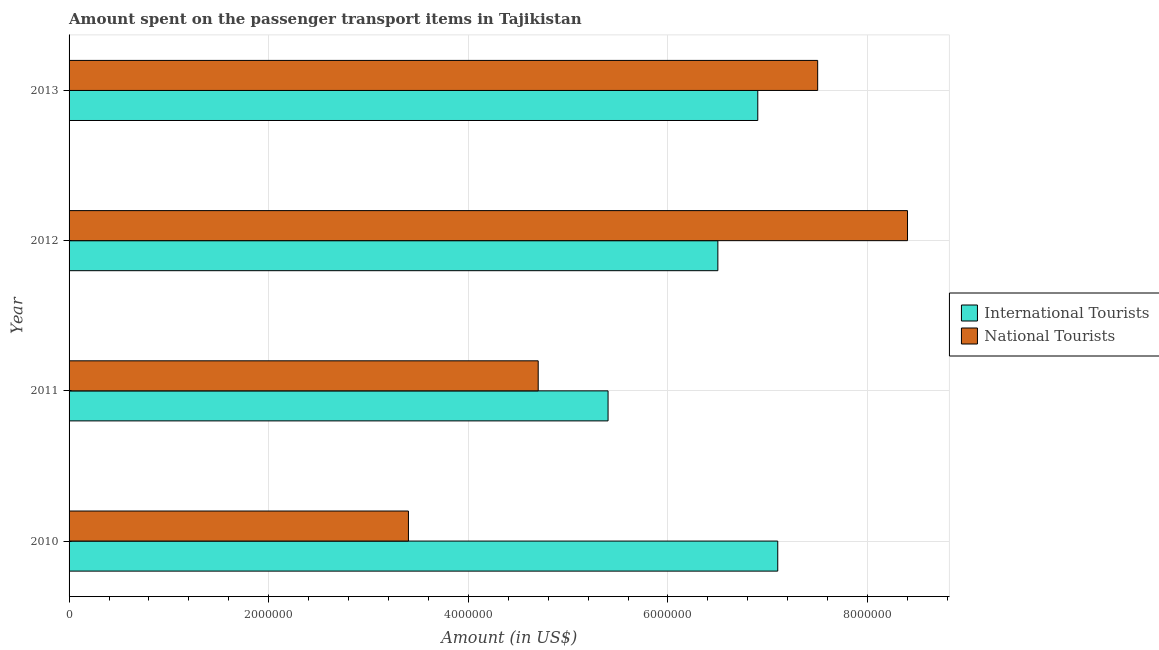How many different coloured bars are there?
Ensure brevity in your answer.  2. Are the number of bars per tick equal to the number of legend labels?
Provide a short and direct response. Yes. What is the amount spent on transport items of national tourists in 2012?
Provide a short and direct response. 8.40e+06. Across all years, what is the maximum amount spent on transport items of international tourists?
Keep it short and to the point. 7.10e+06. Across all years, what is the minimum amount spent on transport items of international tourists?
Your answer should be very brief. 5.40e+06. In which year was the amount spent on transport items of national tourists maximum?
Your response must be concise. 2012. In which year was the amount spent on transport items of national tourists minimum?
Offer a terse response. 2010. What is the total amount spent on transport items of international tourists in the graph?
Your answer should be very brief. 2.59e+07. What is the difference between the amount spent on transport items of national tourists in 2010 and that in 2012?
Give a very brief answer. -5.00e+06. What is the difference between the amount spent on transport items of international tourists in 2011 and the amount spent on transport items of national tourists in 2013?
Provide a short and direct response. -2.10e+06. What is the average amount spent on transport items of international tourists per year?
Offer a very short reply. 6.48e+06. In the year 2012, what is the difference between the amount spent on transport items of national tourists and amount spent on transport items of international tourists?
Your answer should be compact. 1.90e+06. In how many years, is the amount spent on transport items of national tourists greater than 4800000 US$?
Ensure brevity in your answer.  2. What is the ratio of the amount spent on transport items of national tourists in 2010 to that in 2013?
Your response must be concise. 0.45. Is the amount spent on transport items of international tourists in 2011 less than that in 2012?
Your answer should be compact. Yes. Is the difference between the amount spent on transport items of national tourists in 2010 and 2011 greater than the difference between the amount spent on transport items of international tourists in 2010 and 2011?
Offer a very short reply. No. What is the difference between the highest and the lowest amount spent on transport items of national tourists?
Provide a succinct answer. 5.00e+06. In how many years, is the amount spent on transport items of national tourists greater than the average amount spent on transport items of national tourists taken over all years?
Your response must be concise. 2. Is the sum of the amount spent on transport items of national tourists in 2010 and 2012 greater than the maximum amount spent on transport items of international tourists across all years?
Offer a terse response. Yes. What does the 2nd bar from the top in 2010 represents?
Provide a succinct answer. International Tourists. What does the 1st bar from the bottom in 2013 represents?
Your answer should be compact. International Tourists. How many bars are there?
Provide a succinct answer. 8. Does the graph contain grids?
Give a very brief answer. Yes. Where does the legend appear in the graph?
Your response must be concise. Center right. How many legend labels are there?
Give a very brief answer. 2. How are the legend labels stacked?
Give a very brief answer. Vertical. What is the title of the graph?
Provide a short and direct response. Amount spent on the passenger transport items in Tajikistan. What is the Amount (in US$) in International Tourists in 2010?
Your response must be concise. 7.10e+06. What is the Amount (in US$) of National Tourists in 2010?
Provide a succinct answer. 3.40e+06. What is the Amount (in US$) of International Tourists in 2011?
Offer a terse response. 5.40e+06. What is the Amount (in US$) of National Tourists in 2011?
Give a very brief answer. 4.70e+06. What is the Amount (in US$) in International Tourists in 2012?
Ensure brevity in your answer.  6.50e+06. What is the Amount (in US$) of National Tourists in 2012?
Keep it short and to the point. 8.40e+06. What is the Amount (in US$) in International Tourists in 2013?
Provide a succinct answer. 6.90e+06. What is the Amount (in US$) in National Tourists in 2013?
Provide a short and direct response. 7.50e+06. Across all years, what is the maximum Amount (in US$) in International Tourists?
Provide a succinct answer. 7.10e+06. Across all years, what is the maximum Amount (in US$) of National Tourists?
Keep it short and to the point. 8.40e+06. Across all years, what is the minimum Amount (in US$) of International Tourists?
Make the answer very short. 5.40e+06. Across all years, what is the minimum Amount (in US$) in National Tourists?
Offer a terse response. 3.40e+06. What is the total Amount (in US$) of International Tourists in the graph?
Keep it short and to the point. 2.59e+07. What is the total Amount (in US$) of National Tourists in the graph?
Your answer should be very brief. 2.40e+07. What is the difference between the Amount (in US$) of International Tourists in 2010 and that in 2011?
Provide a succinct answer. 1.70e+06. What is the difference between the Amount (in US$) of National Tourists in 2010 and that in 2011?
Ensure brevity in your answer.  -1.30e+06. What is the difference between the Amount (in US$) of International Tourists in 2010 and that in 2012?
Keep it short and to the point. 6.00e+05. What is the difference between the Amount (in US$) of National Tourists in 2010 and that in 2012?
Provide a succinct answer. -5.00e+06. What is the difference between the Amount (in US$) in International Tourists in 2010 and that in 2013?
Offer a terse response. 2.00e+05. What is the difference between the Amount (in US$) in National Tourists in 2010 and that in 2013?
Your answer should be very brief. -4.10e+06. What is the difference between the Amount (in US$) in International Tourists in 2011 and that in 2012?
Make the answer very short. -1.10e+06. What is the difference between the Amount (in US$) of National Tourists in 2011 and that in 2012?
Make the answer very short. -3.70e+06. What is the difference between the Amount (in US$) of International Tourists in 2011 and that in 2013?
Provide a succinct answer. -1.50e+06. What is the difference between the Amount (in US$) of National Tourists in 2011 and that in 2013?
Provide a short and direct response. -2.80e+06. What is the difference between the Amount (in US$) in International Tourists in 2012 and that in 2013?
Your response must be concise. -4.00e+05. What is the difference between the Amount (in US$) of National Tourists in 2012 and that in 2013?
Offer a very short reply. 9.00e+05. What is the difference between the Amount (in US$) of International Tourists in 2010 and the Amount (in US$) of National Tourists in 2011?
Offer a terse response. 2.40e+06. What is the difference between the Amount (in US$) in International Tourists in 2010 and the Amount (in US$) in National Tourists in 2012?
Your answer should be very brief. -1.30e+06. What is the difference between the Amount (in US$) in International Tourists in 2010 and the Amount (in US$) in National Tourists in 2013?
Offer a terse response. -4.00e+05. What is the difference between the Amount (in US$) of International Tourists in 2011 and the Amount (in US$) of National Tourists in 2013?
Provide a succinct answer. -2.10e+06. What is the average Amount (in US$) in International Tourists per year?
Offer a very short reply. 6.48e+06. What is the average Amount (in US$) of National Tourists per year?
Your answer should be compact. 6.00e+06. In the year 2010, what is the difference between the Amount (in US$) of International Tourists and Amount (in US$) of National Tourists?
Your answer should be very brief. 3.70e+06. In the year 2012, what is the difference between the Amount (in US$) of International Tourists and Amount (in US$) of National Tourists?
Provide a short and direct response. -1.90e+06. In the year 2013, what is the difference between the Amount (in US$) of International Tourists and Amount (in US$) of National Tourists?
Offer a terse response. -6.00e+05. What is the ratio of the Amount (in US$) of International Tourists in 2010 to that in 2011?
Offer a terse response. 1.31. What is the ratio of the Amount (in US$) in National Tourists in 2010 to that in 2011?
Provide a short and direct response. 0.72. What is the ratio of the Amount (in US$) of International Tourists in 2010 to that in 2012?
Your response must be concise. 1.09. What is the ratio of the Amount (in US$) in National Tourists in 2010 to that in 2012?
Provide a short and direct response. 0.4. What is the ratio of the Amount (in US$) of International Tourists in 2010 to that in 2013?
Keep it short and to the point. 1.03. What is the ratio of the Amount (in US$) of National Tourists in 2010 to that in 2013?
Your response must be concise. 0.45. What is the ratio of the Amount (in US$) in International Tourists in 2011 to that in 2012?
Your answer should be very brief. 0.83. What is the ratio of the Amount (in US$) of National Tourists in 2011 to that in 2012?
Make the answer very short. 0.56. What is the ratio of the Amount (in US$) of International Tourists in 2011 to that in 2013?
Provide a succinct answer. 0.78. What is the ratio of the Amount (in US$) in National Tourists in 2011 to that in 2013?
Provide a succinct answer. 0.63. What is the ratio of the Amount (in US$) in International Tourists in 2012 to that in 2013?
Give a very brief answer. 0.94. What is the ratio of the Amount (in US$) in National Tourists in 2012 to that in 2013?
Provide a succinct answer. 1.12. What is the difference between the highest and the second highest Amount (in US$) of International Tourists?
Ensure brevity in your answer.  2.00e+05. What is the difference between the highest and the second highest Amount (in US$) in National Tourists?
Provide a succinct answer. 9.00e+05. What is the difference between the highest and the lowest Amount (in US$) in International Tourists?
Offer a very short reply. 1.70e+06. What is the difference between the highest and the lowest Amount (in US$) in National Tourists?
Ensure brevity in your answer.  5.00e+06. 